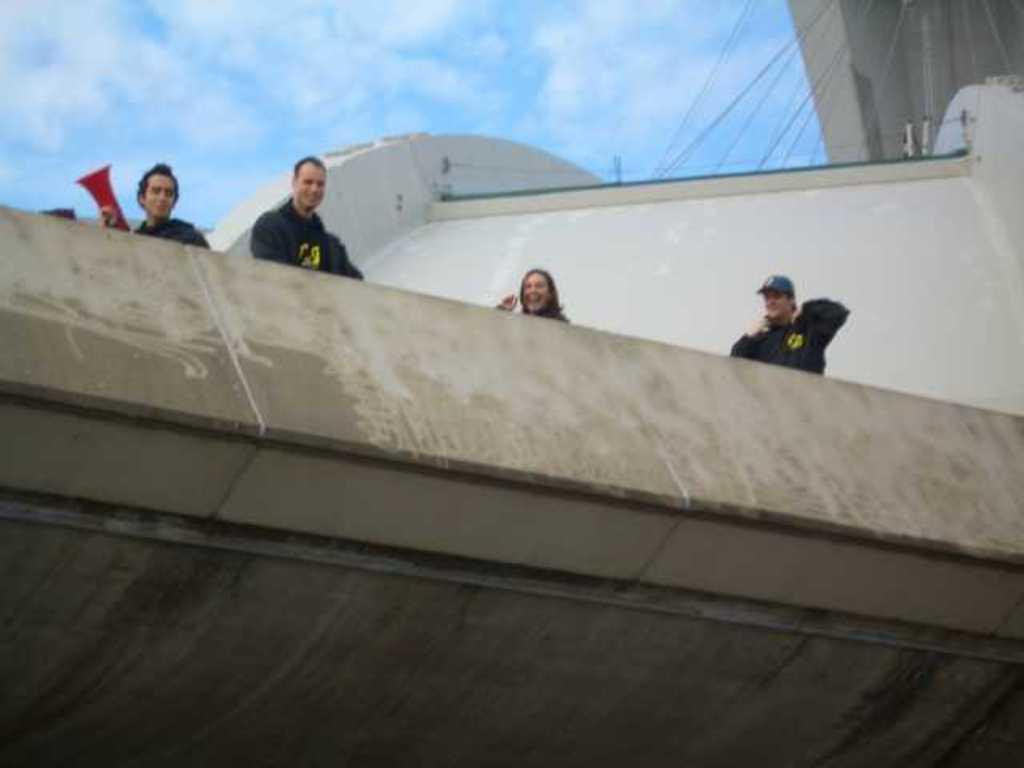Can you describe this image briefly? In this image we can see four persons. In the foreground we can see a wall. Behind the persons we can see a building. At the top we can see the sky. On the top right, we can see few ropes and a wall. 